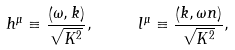<formula> <loc_0><loc_0><loc_500><loc_500>h ^ { \mu } \equiv \frac { \left ( \omega , { k } \right ) } { \sqrt { K ^ { 2 } } } , \text { \quad } l ^ { \mu } \equiv \frac { \left ( k , \omega { n } \right ) } { \sqrt { K ^ { 2 } } } ,</formula> 